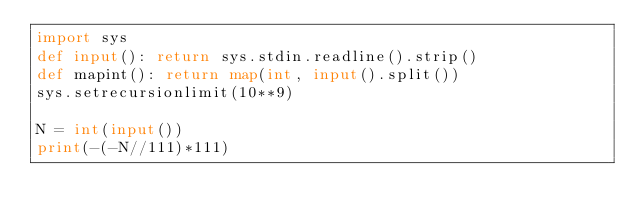<code> <loc_0><loc_0><loc_500><loc_500><_Python_>import sys
def input(): return sys.stdin.readline().strip()
def mapint(): return map(int, input().split())
sys.setrecursionlimit(10**9)

N = int(input())
print(-(-N//111)*111)</code> 